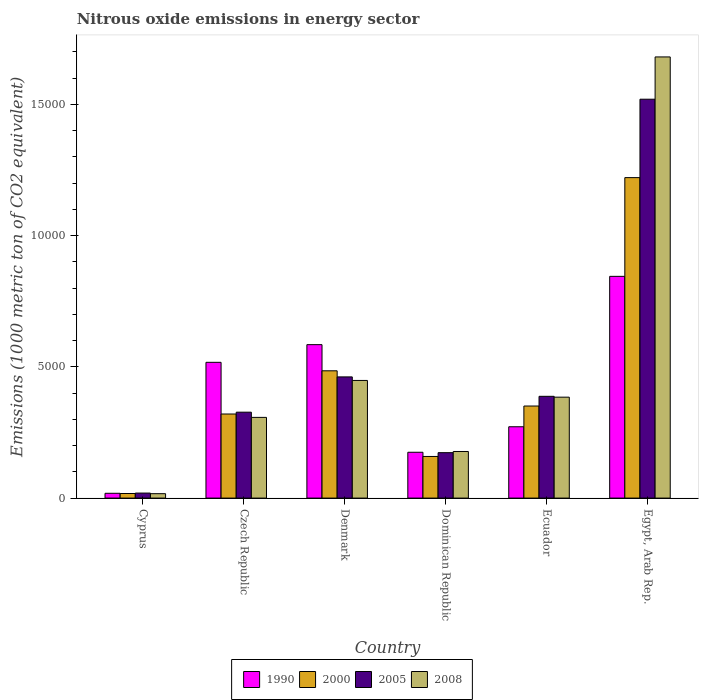How many different coloured bars are there?
Keep it short and to the point. 4. Are the number of bars on each tick of the X-axis equal?
Offer a terse response. Yes. How many bars are there on the 3rd tick from the left?
Ensure brevity in your answer.  4. How many bars are there on the 3rd tick from the right?
Your answer should be compact. 4. What is the label of the 1st group of bars from the left?
Your response must be concise. Cyprus. What is the amount of nitrous oxide emitted in 2008 in Czech Republic?
Provide a short and direct response. 3075.6. Across all countries, what is the maximum amount of nitrous oxide emitted in 2008?
Keep it short and to the point. 1.68e+04. Across all countries, what is the minimum amount of nitrous oxide emitted in 2005?
Your answer should be compact. 191.4. In which country was the amount of nitrous oxide emitted in 2008 maximum?
Provide a succinct answer. Egypt, Arab Rep. In which country was the amount of nitrous oxide emitted in 2005 minimum?
Keep it short and to the point. Cyprus. What is the total amount of nitrous oxide emitted in 2005 in the graph?
Your answer should be compact. 2.89e+04. What is the difference between the amount of nitrous oxide emitted in 2008 in Czech Republic and that in Ecuador?
Provide a short and direct response. -770.4. What is the difference between the amount of nitrous oxide emitted in 2008 in Denmark and the amount of nitrous oxide emitted in 1990 in Ecuador?
Your answer should be very brief. 1764.9. What is the average amount of nitrous oxide emitted in 2008 per country?
Your answer should be very brief. 5026.67. What is the difference between the amount of nitrous oxide emitted of/in 2000 and amount of nitrous oxide emitted of/in 2005 in Czech Republic?
Give a very brief answer. -69.6. What is the ratio of the amount of nitrous oxide emitted in 2008 in Czech Republic to that in Dominican Republic?
Offer a terse response. 1.73. What is the difference between the highest and the second highest amount of nitrous oxide emitted in 1990?
Give a very brief answer. 3275.8. What is the difference between the highest and the lowest amount of nitrous oxide emitted in 2005?
Provide a succinct answer. 1.50e+04. In how many countries, is the amount of nitrous oxide emitted in 2008 greater than the average amount of nitrous oxide emitted in 2008 taken over all countries?
Your response must be concise. 1. Is the sum of the amount of nitrous oxide emitted in 2000 in Cyprus and Egypt, Arab Rep. greater than the maximum amount of nitrous oxide emitted in 2008 across all countries?
Keep it short and to the point. No. What does the 2nd bar from the left in Cyprus represents?
Make the answer very short. 2000. How many countries are there in the graph?
Make the answer very short. 6. What is the difference between two consecutive major ticks on the Y-axis?
Give a very brief answer. 5000. Are the values on the major ticks of Y-axis written in scientific E-notation?
Offer a very short reply. No. Does the graph contain any zero values?
Keep it short and to the point. No. How many legend labels are there?
Your answer should be very brief. 4. What is the title of the graph?
Give a very brief answer. Nitrous oxide emissions in energy sector. What is the label or title of the X-axis?
Your answer should be very brief. Country. What is the label or title of the Y-axis?
Give a very brief answer. Emissions (1000 metric ton of CO2 equivalent). What is the Emissions (1000 metric ton of CO2 equivalent) in 1990 in Cyprus?
Make the answer very short. 182.9. What is the Emissions (1000 metric ton of CO2 equivalent) in 2000 in Cyprus?
Offer a terse response. 174.6. What is the Emissions (1000 metric ton of CO2 equivalent) of 2005 in Cyprus?
Your response must be concise. 191.4. What is the Emissions (1000 metric ton of CO2 equivalent) in 2008 in Cyprus?
Your answer should be very brief. 167.9. What is the Emissions (1000 metric ton of CO2 equivalent) in 1990 in Czech Republic?
Provide a short and direct response. 5174.1. What is the Emissions (1000 metric ton of CO2 equivalent) in 2000 in Czech Republic?
Give a very brief answer. 3204.1. What is the Emissions (1000 metric ton of CO2 equivalent) of 2005 in Czech Republic?
Offer a very short reply. 3273.7. What is the Emissions (1000 metric ton of CO2 equivalent) of 2008 in Czech Republic?
Your response must be concise. 3075.6. What is the Emissions (1000 metric ton of CO2 equivalent) in 1990 in Denmark?
Give a very brief answer. 5847.4. What is the Emissions (1000 metric ton of CO2 equivalent) of 2000 in Denmark?
Provide a short and direct response. 4850.8. What is the Emissions (1000 metric ton of CO2 equivalent) in 2005 in Denmark?
Offer a very short reply. 4618.6. What is the Emissions (1000 metric ton of CO2 equivalent) of 2008 in Denmark?
Your answer should be compact. 4483.4. What is the Emissions (1000 metric ton of CO2 equivalent) of 1990 in Dominican Republic?
Your response must be concise. 1746.5. What is the Emissions (1000 metric ton of CO2 equivalent) of 2000 in Dominican Republic?
Give a very brief answer. 1586.4. What is the Emissions (1000 metric ton of CO2 equivalent) of 2005 in Dominican Republic?
Make the answer very short. 1731. What is the Emissions (1000 metric ton of CO2 equivalent) in 2008 in Dominican Republic?
Your answer should be very brief. 1775.7. What is the Emissions (1000 metric ton of CO2 equivalent) of 1990 in Ecuador?
Provide a short and direct response. 2718.5. What is the Emissions (1000 metric ton of CO2 equivalent) in 2000 in Ecuador?
Provide a short and direct response. 3508.3. What is the Emissions (1000 metric ton of CO2 equivalent) of 2005 in Ecuador?
Your answer should be very brief. 3878.5. What is the Emissions (1000 metric ton of CO2 equivalent) in 2008 in Ecuador?
Keep it short and to the point. 3846. What is the Emissions (1000 metric ton of CO2 equivalent) in 1990 in Egypt, Arab Rep.?
Provide a short and direct response. 8449.9. What is the Emissions (1000 metric ton of CO2 equivalent) of 2000 in Egypt, Arab Rep.?
Make the answer very short. 1.22e+04. What is the Emissions (1000 metric ton of CO2 equivalent) of 2005 in Egypt, Arab Rep.?
Your response must be concise. 1.52e+04. What is the Emissions (1000 metric ton of CO2 equivalent) in 2008 in Egypt, Arab Rep.?
Keep it short and to the point. 1.68e+04. Across all countries, what is the maximum Emissions (1000 metric ton of CO2 equivalent) in 1990?
Give a very brief answer. 8449.9. Across all countries, what is the maximum Emissions (1000 metric ton of CO2 equivalent) in 2000?
Your response must be concise. 1.22e+04. Across all countries, what is the maximum Emissions (1000 metric ton of CO2 equivalent) of 2005?
Your answer should be compact. 1.52e+04. Across all countries, what is the maximum Emissions (1000 metric ton of CO2 equivalent) of 2008?
Keep it short and to the point. 1.68e+04. Across all countries, what is the minimum Emissions (1000 metric ton of CO2 equivalent) of 1990?
Your answer should be very brief. 182.9. Across all countries, what is the minimum Emissions (1000 metric ton of CO2 equivalent) in 2000?
Give a very brief answer. 174.6. Across all countries, what is the minimum Emissions (1000 metric ton of CO2 equivalent) of 2005?
Your answer should be very brief. 191.4. Across all countries, what is the minimum Emissions (1000 metric ton of CO2 equivalent) in 2008?
Give a very brief answer. 167.9. What is the total Emissions (1000 metric ton of CO2 equivalent) of 1990 in the graph?
Provide a short and direct response. 2.41e+04. What is the total Emissions (1000 metric ton of CO2 equivalent) in 2000 in the graph?
Your answer should be very brief. 2.55e+04. What is the total Emissions (1000 metric ton of CO2 equivalent) in 2005 in the graph?
Keep it short and to the point. 2.89e+04. What is the total Emissions (1000 metric ton of CO2 equivalent) of 2008 in the graph?
Make the answer very short. 3.02e+04. What is the difference between the Emissions (1000 metric ton of CO2 equivalent) in 1990 in Cyprus and that in Czech Republic?
Offer a terse response. -4991.2. What is the difference between the Emissions (1000 metric ton of CO2 equivalent) of 2000 in Cyprus and that in Czech Republic?
Ensure brevity in your answer.  -3029.5. What is the difference between the Emissions (1000 metric ton of CO2 equivalent) in 2005 in Cyprus and that in Czech Republic?
Your answer should be compact. -3082.3. What is the difference between the Emissions (1000 metric ton of CO2 equivalent) of 2008 in Cyprus and that in Czech Republic?
Offer a terse response. -2907.7. What is the difference between the Emissions (1000 metric ton of CO2 equivalent) of 1990 in Cyprus and that in Denmark?
Ensure brevity in your answer.  -5664.5. What is the difference between the Emissions (1000 metric ton of CO2 equivalent) in 2000 in Cyprus and that in Denmark?
Provide a succinct answer. -4676.2. What is the difference between the Emissions (1000 metric ton of CO2 equivalent) of 2005 in Cyprus and that in Denmark?
Keep it short and to the point. -4427.2. What is the difference between the Emissions (1000 metric ton of CO2 equivalent) of 2008 in Cyprus and that in Denmark?
Offer a terse response. -4315.5. What is the difference between the Emissions (1000 metric ton of CO2 equivalent) in 1990 in Cyprus and that in Dominican Republic?
Give a very brief answer. -1563.6. What is the difference between the Emissions (1000 metric ton of CO2 equivalent) in 2000 in Cyprus and that in Dominican Republic?
Provide a short and direct response. -1411.8. What is the difference between the Emissions (1000 metric ton of CO2 equivalent) in 2005 in Cyprus and that in Dominican Republic?
Provide a short and direct response. -1539.6. What is the difference between the Emissions (1000 metric ton of CO2 equivalent) of 2008 in Cyprus and that in Dominican Republic?
Your answer should be very brief. -1607.8. What is the difference between the Emissions (1000 metric ton of CO2 equivalent) in 1990 in Cyprus and that in Ecuador?
Keep it short and to the point. -2535.6. What is the difference between the Emissions (1000 metric ton of CO2 equivalent) in 2000 in Cyprus and that in Ecuador?
Give a very brief answer. -3333.7. What is the difference between the Emissions (1000 metric ton of CO2 equivalent) in 2005 in Cyprus and that in Ecuador?
Give a very brief answer. -3687.1. What is the difference between the Emissions (1000 metric ton of CO2 equivalent) in 2008 in Cyprus and that in Ecuador?
Keep it short and to the point. -3678.1. What is the difference between the Emissions (1000 metric ton of CO2 equivalent) of 1990 in Cyprus and that in Egypt, Arab Rep.?
Provide a succinct answer. -8267. What is the difference between the Emissions (1000 metric ton of CO2 equivalent) in 2000 in Cyprus and that in Egypt, Arab Rep.?
Your answer should be very brief. -1.20e+04. What is the difference between the Emissions (1000 metric ton of CO2 equivalent) of 2005 in Cyprus and that in Egypt, Arab Rep.?
Ensure brevity in your answer.  -1.50e+04. What is the difference between the Emissions (1000 metric ton of CO2 equivalent) of 2008 in Cyprus and that in Egypt, Arab Rep.?
Your answer should be very brief. -1.66e+04. What is the difference between the Emissions (1000 metric ton of CO2 equivalent) in 1990 in Czech Republic and that in Denmark?
Your answer should be very brief. -673.3. What is the difference between the Emissions (1000 metric ton of CO2 equivalent) in 2000 in Czech Republic and that in Denmark?
Provide a short and direct response. -1646.7. What is the difference between the Emissions (1000 metric ton of CO2 equivalent) in 2005 in Czech Republic and that in Denmark?
Offer a terse response. -1344.9. What is the difference between the Emissions (1000 metric ton of CO2 equivalent) in 2008 in Czech Republic and that in Denmark?
Keep it short and to the point. -1407.8. What is the difference between the Emissions (1000 metric ton of CO2 equivalent) in 1990 in Czech Republic and that in Dominican Republic?
Your response must be concise. 3427.6. What is the difference between the Emissions (1000 metric ton of CO2 equivalent) in 2000 in Czech Republic and that in Dominican Republic?
Provide a short and direct response. 1617.7. What is the difference between the Emissions (1000 metric ton of CO2 equivalent) of 2005 in Czech Republic and that in Dominican Republic?
Ensure brevity in your answer.  1542.7. What is the difference between the Emissions (1000 metric ton of CO2 equivalent) of 2008 in Czech Republic and that in Dominican Republic?
Give a very brief answer. 1299.9. What is the difference between the Emissions (1000 metric ton of CO2 equivalent) in 1990 in Czech Republic and that in Ecuador?
Offer a very short reply. 2455.6. What is the difference between the Emissions (1000 metric ton of CO2 equivalent) in 2000 in Czech Republic and that in Ecuador?
Your response must be concise. -304.2. What is the difference between the Emissions (1000 metric ton of CO2 equivalent) in 2005 in Czech Republic and that in Ecuador?
Provide a succinct answer. -604.8. What is the difference between the Emissions (1000 metric ton of CO2 equivalent) in 2008 in Czech Republic and that in Ecuador?
Offer a very short reply. -770.4. What is the difference between the Emissions (1000 metric ton of CO2 equivalent) in 1990 in Czech Republic and that in Egypt, Arab Rep.?
Give a very brief answer. -3275.8. What is the difference between the Emissions (1000 metric ton of CO2 equivalent) in 2000 in Czech Republic and that in Egypt, Arab Rep.?
Offer a very short reply. -9008.3. What is the difference between the Emissions (1000 metric ton of CO2 equivalent) in 2005 in Czech Republic and that in Egypt, Arab Rep.?
Your response must be concise. -1.19e+04. What is the difference between the Emissions (1000 metric ton of CO2 equivalent) in 2008 in Czech Republic and that in Egypt, Arab Rep.?
Provide a succinct answer. -1.37e+04. What is the difference between the Emissions (1000 metric ton of CO2 equivalent) of 1990 in Denmark and that in Dominican Republic?
Offer a terse response. 4100.9. What is the difference between the Emissions (1000 metric ton of CO2 equivalent) of 2000 in Denmark and that in Dominican Republic?
Make the answer very short. 3264.4. What is the difference between the Emissions (1000 metric ton of CO2 equivalent) in 2005 in Denmark and that in Dominican Republic?
Give a very brief answer. 2887.6. What is the difference between the Emissions (1000 metric ton of CO2 equivalent) in 2008 in Denmark and that in Dominican Republic?
Keep it short and to the point. 2707.7. What is the difference between the Emissions (1000 metric ton of CO2 equivalent) of 1990 in Denmark and that in Ecuador?
Provide a succinct answer. 3128.9. What is the difference between the Emissions (1000 metric ton of CO2 equivalent) in 2000 in Denmark and that in Ecuador?
Give a very brief answer. 1342.5. What is the difference between the Emissions (1000 metric ton of CO2 equivalent) in 2005 in Denmark and that in Ecuador?
Give a very brief answer. 740.1. What is the difference between the Emissions (1000 metric ton of CO2 equivalent) in 2008 in Denmark and that in Ecuador?
Ensure brevity in your answer.  637.4. What is the difference between the Emissions (1000 metric ton of CO2 equivalent) in 1990 in Denmark and that in Egypt, Arab Rep.?
Give a very brief answer. -2602.5. What is the difference between the Emissions (1000 metric ton of CO2 equivalent) in 2000 in Denmark and that in Egypt, Arab Rep.?
Provide a succinct answer. -7361.6. What is the difference between the Emissions (1000 metric ton of CO2 equivalent) of 2005 in Denmark and that in Egypt, Arab Rep.?
Give a very brief answer. -1.06e+04. What is the difference between the Emissions (1000 metric ton of CO2 equivalent) of 2008 in Denmark and that in Egypt, Arab Rep.?
Keep it short and to the point. -1.23e+04. What is the difference between the Emissions (1000 metric ton of CO2 equivalent) of 1990 in Dominican Republic and that in Ecuador?
Offer a very short reply. -972. What is the difference between the Emissions (1000 metric ton of CO2 equivalent) of 2000 in Dominican Republic and that in Ecuador?
Your answer should be compact. -1921.9. What is the difference between the Emissions (1000 metric ton of CO2 equivalent) of 2005 in Dominican Republic and that in Ecuador?
Ensure brevity in your answer.  -2147.5. What is the difference between the Emissions (1000 metric ton of CO2 equivalent) of 2008 in Dominican Republic and that in Ecuador?
Offer a very short reply. -2070.3. What is the difference between the Emissions (1000 metric ton of CO2 equivalent) in 1990 in Dominican Republic and that in Egypt, Arab Rep.?
Your answer should be compact. -6703.4. What is the difference between the Emissions (1000 metric ton of CO2 equivalent) in 2000 in Dominican Republic and that in Egypt, Arab Rep.?
Your answer should be very brief. -1.06e+04. What is the difference between the Emissions (1000 metric ton of CO2 equivalent) in 2005 in Dominican Republic and that in Egypt, Arab Rep.?
Your response must be concise. -1.35e+04. What is the difference between the Emissions (1000 metric ton of CO2 equivalent) in 2008 in Dominican Republic and that in Egypt, Arab Rep.?
Provide a succinct answer. -1.50e+04. What is the difference between the Emissions (1000 metric ton of CO2 equivalent) of 1990 in Ecuador and that in Egypt, Arab Rep.?
Your response must be concise. -5731.4. What is the difference between the Emissions (1000 metric ton of CO2 equivalent) of 2000 in Ecuador and that in Egypt, Arab Rep.?
Your answer should be compact. -8704.1. What is the difference between the Emissions (1000 metric ton of CO2 equivalent) of 2005 in Ecuador and that in Egypt, Arab Rep.?
Offer a terse response. -1.13e+04. What is the difference between the Emissions (1000 metric ton of CO2 equivalent) of 2008 in Ecuador and that in Egypt, Arab Rep.?
Your response must be concise. -1.30e+04. What is the difference between the Emissions (1000 metric ton of CO2 equivalent) in 1990 in Cyprus and the Emissions (1000 metric ton of CO2 equivalent) in 2000 in Czech Republic?
Give a very brief answer. -3021.2. What is the difference between the Emissions (1000 metric ton of CO2 equivalent) in 1990 in Cyprus and the Emissions (1000 metric ton of CO2 equivalent) in 2005 in Czech Republic?
Offer a terse response. -3090.8. What is the difference between the Emissions (1000 metric ton of CO2 equivalent) of 1990 in Cyprus and the Emissions (1000 metric ton of CO2 equivalent) of 2008 in Czech Republic?
Offer a very short reply. -2892.7. What is the difference between the Emissions (1000 metric ton of CO2 equivalent) in 2000 in Cyprus and the Emissions (1000 metric ton of CO2 equivalent) in 2005 in Czech Republic?
Offer a terse response. -3099.1. What is the difference between the Emissions (1000 metric ton of CO2 equivalent) in 2000 in Cyprus and the Emissions (1000 metric ton of CO2 equivalent) in 2008 in Czech Republic?
Offer a very short reply. -2901. What is the difference between the Emissions (1000 metric ton of CO2 equivalent) of 2005 in Cyprus and the Emissions (1000 metric ton of CO2 equivalent) of 2008 in Czech Republic?
Your response must be concise. -2884.2. What is the difference between the Emissions (1000 metric ton of CO2 equivalent) in 1990 in Cyprus and the Emissions (1000 metric ton of CO2 equivalent) in 2000 in Denmark?
Your answer should be compact. -4667.9. What is the difference between the Emissions (1000 metric ton of CO2 equivalent) of 1990 in Cyprus and the Emissions (1000 metric ton of CO2 equivalent) of 2005 in Denmark?
Your answer should be very brief. -4435.7. What is the difference between the Emissions (1000 metric ton of CO2 equivalent) in 1990 in Cyprus and the Emissions (1000 metric ton of CO2 equivalent) in 2008 in Denmark?
Provide a short and direct response. -4300.5. What is the difference between the Emissions (1000 metric ton of CO2 equivalent) in 2000 in Cyprus and the Emissions (1000 metric ton of CO2 equivalent) in 2005 in Denmark?
Offer a terse response. -4444. What is the difference between the Emissions (1000 metric ton of CO2 equivalent) in 2000 in Cyprus and the Emissions (1000 metric ton of CO2 equivalent) in 2008 in Denmark?
Offer a very short reply. -4308.8. What is the difference between the Emissions (1000 metric ton of CO2 equivalent) in 2005 in Cyprus and the Emissions (1000 metric ton of CO2 equivalent) in 2008 in Denmark?
Provide a short and direct response. -4292. What is the difference between the Emissions (1000 metric ton of CO2 equivalent) in 1990 in Cyprus and the Emissions (1000 metric ton of CO2 equivalent) in 2000 in Dominican Republic?
Your answer should be very brief. -1403.5. What is the difference between the Emissions (1000 metric ton of CO2 equivalent) of 1990 in Cyprus and the Emissions (1000 metric ton of CO2 equivalent) of 2005 in Dominican Republic?
Provide a short and direct response. -1548.1. What is the difference between the Emissions (1000 metric ton of CO2 equivalent) in 1990 in Cyprus and the Emissions (1000 metric ton of CO2 equivalent) in 2008 in Dominican Republic?
Your answer should be very brief. -1592.8. What is the difference between the Emissions (1000 metric ton of CO2 equivalent) of 2000 in Cyprus and the Emissions (1000 metric ton of CO2 equivalent) of 2005 in Dominican Republic?
Keep it short and to the point. -1556.4. What is the difference between the Emissions (1000 metric ton of CO2 equivalent) of 2000 in Cyprus and the Emissions (1000 metric ton of CO2 equivalent) of 2008 in Dominican Republic?
Make the answer very short. -1601.1. What is the difference between the Emissions (1000 metric ton of CO2 equivalent) of 2005 in Cyprus and the Emissions (1000 metric ton of CO2 equivalent) of 2008 in Dominican Republic?
Keep it short and to the point. -1584.3. What is the difference between the Emissions (1000 metric ton of CO2 equivalent) of 1990 in Cyprus and the Emissions (1000 metric ton of CO2 equivalent) of 2000 in Ecuador?
Your answer should be compact. -3325.4. What is the difference between the Emissions (1000 metric ton of CO2 equivalent) in 1990 in Cyprus and the Emissions (1000 metric ton of CO2 equivalent) in 2005 in Ecuador?
Offer a terse response. -3695.6. What is the difference between the Emissions (1000 metric ton of CO2 equivalent) in 1990 in Cyprus and the Emissions (1000 metric ton of CO2 equivalent) in 2008 in Ecuador?
Make the answer very short. -3663.1. What is the difference between the Emissions (1000 metric ton of CO2 equivalent) in 2000 in Cyprus and the Emissions (1000 metric ton of CO2 equivalent) in 2005 in Ecuador?
Ensure brevity in your answer.  -3703.9. What is the difference between the Emissions (1000 metric ton of CO2 equivalent) of 2000 in Cyprus and the Emissions (1000 metric ton of CO2 equivalent) of 2008 in Ecuador?
Make the answer very short. -3671.4. What is the difference between the Emissions (1000 metric ton of CO2 equivalent) in 2005 in Cyprus and the Emissions (1000 metric ton of CO2 equivalent) in 2008 in Ecuador?
Your answer should be very brief. -3654.6. What is the difference between the Emissions (1000 metric ton of CO2 equivalent) in 1990 in Cyprus and the Emissions (1000 metric ton of CO2 equivalent) in 2000 in Egypt, Arab Rep.?
Your answer should be very brief. -1.20e+04. What is the difference between the Emissions (1000 metric ton of CO2 equivalent) of 1990 in Cyprus and the Emissions (1000 metric ton of CO2 equivalent) of 2005 in Egypt, Arab Rep.?
Make the answer very short. -1.50e+04. What is the difference between the Emissions (1000 metric ton of CO2 equivalent) in 1990 in Cyprus and the Emissions (1000 metric ton of CO2 equivalent) in 2008 in Egypt, Arab Rep.?
Make the answer very short. -1.66e+04. What is the difference between the Emissions (1000 metric ton of CO2 equivalent) of 2000 in Cyprus and the Emissions (1000 metric ton of CO2 equivalent) of 2005 in Egypt, Arab Rep.?
Offer a terse response. -1.50e+04. What is the difference between the Emissions (1000 metric ton of CO2 equivalent) of 2000 in Cyprus and the Emissions (1000 metric ton of CO2 equivalent) of 2008 in Egypt, Arab Rep.?
Your response must be concise. -1.66e+04. What is the difference between the Emissions (1000 metric ton of CO2 equivalent) of 2005 in Cyprus and the Emissions (1000 metric ton of CO2 equivalent) of 2008 in Egypt, Arab Rep.?
Provide a succinct answer. -1.66e+04. What is the difference between the Emissions (1000 metric ton of CO2 equivalent) of 1990 in Czech Republic and the Emissions (1000 metric ton of CO2 equivalent) of 2000 in Denmark?
Ensure brevity in your answer.  323.3. What is the difference between the Emissions (1000 metric ton of CO2 equivalent) in 1990 in Czech Republic and the Emissions (1000 metric ton of CO2 equivalent) in 2005 in Denmark?
Your answer should be compact. 555.5. What is the difference between the Emissions (1000 metric ton of CO2 equivalent) of 1990 in Czech Republic and the Emissions (1000 metric ton of CO2 equivalent) of 2008 in Denmark?
Provide a short and direct response. 690.7. What is the difference between the Emissions (1000 metric ton of CO2 equivalent) of 2000 in Czech Republic and the Emissions (1000 metric ton of CO2 equivalent) of 2005 in Denmark?
Offer a terse response. -1414.5. What is the difference between the Emissions (1000 metric ton of CO2 equivalent) of 2000 in Czech Republic and the Emissions (1000 metric ton of CO2 equivalent) of 2008 in Denmark?
Keep it short and to the point. -1279.3. What is the difference between the Emissions (1000 metric ton of CO2 equivalent) in 2005 in Czech Republic and the Emissions (1000 metric ton of CO2 equivalent) in 2008 in Denmark?
Offer a terse response. -1209.7. What is the difference between the Emissions (1000 metric ton of CO2 equivalent) of 1990 in Czech Republic and the Emissions (1000 metric ton of CO2 equivalent) of 2000 in Dominican Republic?
Your answer should be very brief. 3587.7. What is the difference between the Emissions (1000 metric ton of CO2 equivalent) in 1990 in Czech Republic and the Emissions (1000 metric ton of CO2 equivalent) in 2005 in Dominican Republic?
Your answer should be compact. 3443.1. What is the difference between the Emissions (1000 metric ton of CO2 equivalent) of 1990 in Czech Republic and the Emissions (1000 metric ton of CO2 equivalent) of 2008 in Dominican Republic?
Offer a very short reply. 3398.4. What is the difference between the Emissions (1000 metric ton of CO2 equivalent) of 2000 in Czech Republic and the Emissions (1000 metric ton of CO2 equivalent) of 2005 in Dominican Republic?
Offer a very short reply. 1473.1. What is the difference between the Emissions (1000 metric ton of CO2 equivalent) of 2000 in Czech Republic and the Emissions (1000 metric ton of CO2 equivalent) of 2008 in Dominican Republic?
Make the answer very short. 1428.4. What is the difference between the Emissions (1000 metric ton of CO2 equivalent) of 2005 in Czech Republic and the Emissions (1000 metric ton of CO2 equivalent) of 2008 in Dominican Republic?
Your answer should be very brief. 1498. What is the difference between the Emissions (1000 metric ton of CO2 equivalent) in 1990 in Czech Republic and the Emissions (1000 metric ton of CO2 equivalent) in 2000 in Ecuador?
Give a very brief answer. 1665.8. What is the difference between the Emissions (1000 metric ton of CO2 equivalent) in 1990 in Czech Republic and the Emissions (1000 metric ton of CO2 equivalent) in 2005 in Ecuador?
Give a very brief answer. 1295.6. What is the difference between the Emissions (1000 metric ton of CO2 equivalent) in 1990 in Czech Republic and the Emissions (1000 metric ton of CO2 equivalent) in 2008 in Ecuador?
Make the answer very short. 1328.1. What is the difference between the Emissions (1000 metric ton of CO2 equivalent) in 2000 in Czech Republic and the Emissions (1000 metric ton of CO2 equivalent) in 2005 in Ecuador?
Provide a short and direct response. -674.4. What is the difference between the Emissions (1000 metric ton of CO2 equivalent) in 2000 in Czech Republic and the Emissions (1000 metric ton of CO2 equivalent) in 2008 in Ecuador?
Offer a very short reply. -641.9. What is the difference between the Emissions (1000 metric ton of CO2 equivalent) in 2005 in Czech Republic and the Emissions (1000 metric ton of CO2 equivalent) in 2008 in Ecuador?
Provide a short and direct response. -572.3. What is the difference between the Emissions (1000 metric ton of CO2 equivalent) of 1990 in Czech Republic and the Emissions (1000 metric ton of CO2 equivalent) of 2000 in Egypt, Arab Rep.?
Offer a terse response. -7038.3. What is the difference between the Emissions (1000 metric ton of CO2 equivalent) of 1990 in Czech Republic and the Emissions (1000 metric ton of CO2 equivalent) of 2005 in Egypt, Arab Rep.?
Give a very brief answer. -1.00e+04. What is the difference between the Emissions (1000 metric ton of CO2 equivalent) of 1990 in Czech Republic and the Emissions (1000 metric ton of CO2 equivalent) of 2008 in Egypt, Arab Rep.?
Your answer should be compact. -1.16e+04. What is the difference between the Emissions (1000 metric ton of CO2 equivalent) in 2000 in Czech Republic and the Emissions (1000 metric ton of CO2 equivalent) in 2005 in Egypt, Arab Rep.?
Keep it short and to the point. -1.20e+04. What is the difference between the Emissions (1000 metric ton of CO2 equivalent) in 2000 in Czech Republic and the Emissions (1000 metric ton of CO2 equivalent) in 2008 in Egypt, Arab Rep.?
Keep it short and to the point. -1.36e+04. What is the difference between the Emissions (1000 metric ton of CO2 equivalent) of 2005 in Czech Republic and the Emissions (1000 metric ton of CO2 equivalent) of 2008 in Egypt, Arab Rep.?
Give a very brief answer. -1.35e+04. What is the difference between the Emissions (1000 metric ton of CO2 equivalent) in 1990 in Denmark and the Emissions (1000 metric ton of CO2 equivalent) in 2000 in Dominican Republic?
Offer a very short reply. 4261. What is the difference between the Emissions (1000 metric ton of CO2 equivalent) of 1990 in Denmark and the Emissions (1000 metric ton of CO2 equivalent) of 2005 in Dominican Republic?
Offer a very short reply. 4116.4. What is the difference between the Emissions (1000 metric ton of CO2 equivalent) of 1990 in Denmark and the Emissions (1000 metric ton of CO2 equivalent) of 2008 in Dominican Republic?
Offer a very short reply. 4071.7. What is the difference between the Emissions (1000 metric ton of CO2 equivalent) of 2000 in Denmark and the Emissions (1000 metric ton of CO2 equivalent) of 2005 in Dominican Republic?
Provide a short and direct response. 3119.8. What is the difference between the Emissions (1000 metric ton of CO2 equivalent) of 2000 in Denmark and the Emissions (1000 metric ton of CO2 equivalent) of 2008 in Dominican Republic?
Keep it short and to the point. 3075.1. What is the difference between the Emissions (1000 metric ton of CO2 equivalent) of 2005 in Denmark and the Emissions (1000 metric ton of CO2 equivalent) of 2008 in Dominican Republic?
Provide a succinct answer. 2842.9. What is the difference between the Emissions (1000 metric ton of CO2 equivalent) of 1990 in Denmark and the Emissions (1000 metric ton of CO2 equivalent) of 2000 in Ecuador?
Ensure brevity in your answer.  2339.1. What is the difference between the Emissions (1000 metric ton of CO2 equivalent) in 1990 in Denmark and the Emissions (1000 metric ton of CO2 equivalent) in 2005 in Ecuador?
Your answer should be compact. 1968.9. What is the difference between the Emissions (1000 metric ton of CO2 equivalent) of 1990 in Denmark and the Emissions (1000 metric ton of CO2 equivalent) of 2008 in Ecuador?
Make the answer very short. 2001.4. What is the difference between the Emissions (1000 metric ton of CO2 equivalent) in 2000 in Denmark and the Emissions (1000 metric ton of CO2 equivalent) in 2005 in Ecuador?
Ensure brevity in your answer.  972.3. What is the difference between the Emissions (1000 metric ton of CO2 equivalent) in 2000 in Denmark and the Emissions (1000 metric ton of CO2 equivalent) in 2008 in Ecuador?
Give a very brief answer. 1004.8. What is the difference between the Emissions (1000 metric ton of CO2 equivalent) in 2005 in Denmark and the Emissions (1000 metric ton of CO2 equivalent) in 2008 in Ecuador?
Give a very brief answer. 772.6. What is the difference between the Emissions (1000 metric ton of CO2 equivalent) in 1990 in Denmark and the Emissions (1000 metric ton of CO2 equivalent) in 2000 in Egypt, Arab Rep.?
Your answer should be compact. -6365. What is the difference between the Emissions (1000 metric ton of CO2 equivalent) of 1990 in Denmark and the Emissions (1000 metric ton of CO2 equivalent) of 2005 in Egypt, Arab Rep.?
Offer a terse response. -9352.6. What is the difference between the Emissions (1000 metric ton of CO2 equivalent) of 1990 in Denmark and the Emissions (1000 metric ton of CO2 equivalent) of 2008 in Egypt, Arab Rep.?
Keep it short and to the point. -1.10e+04. What is the difference between the Emissions (1000 metric ton of CO2 equivalent) in 2000 in Denmark and the Emissions (1000 metric ton of CO2 equivalent) in 2005 in Egypt, Arab Rep.?
Provide a short and direct response. -1.03e+04. What is the difference between the Emissions (1000 metric ton of CO2 equivalent) of 2000 in Denmark and the Emissions (1000 metric ton of CO2 equivalent) of 2008 in Egypt, Arab Rep.?
Keep it short and to the point. -1.20e+04. What is the difference between the Emissions (1000 metric ton of CO2 equivalent) in 2005 in Denmark and the Emissions (1000 metric ton of CO2 equivalent) in 2008 in Egypt, Arab Rep.?
Give a very brief answer. -1.22e+04. What is the difference between the Emissions (1000 metric ton of CO2 equivalent) of 1990 in Dominican Republic and the Emissions (1000 metric ton of CO2 equivalent) of 2000 in Ecuador?
Your response must be concise. -1761.8. What is the difference between the Emissions (1000 metric ton of CO2 equivalent) in 1990 in Dominican Republic and the Emissions (1000 metric ton of CO2 equivalent) in 2005 in Ecuador?
Offer a terse response. -2132. What is the difference between the Emissions (1000 metric ton of CO2 equivalent) in 1990 in Dominican Republic and the Emissions (1000 metric ton of CO2 equivalent) in 2008 in Ecuador?
Offer a very short reply. -2099.5. What is the difference between the Emissions (1000 metric ton of CO2 equivalent) in 2000 in Dominican Republic and the Emissions (1000 metric ton of CO2 equivalent) in 2005 in Ecuador?
Your answer should be very brief. -2292.1. What is the difference between the Emissions (1000 metric ton of CO2 equivalent) in 2000 in Dominican Republic and the Emissions (1000 metric ton of CO2 equivalent) in 2008 in Ecuador?
Your answer should be compact. -2259.6. What is the difference between the Emissions (1000 metric ton of CO2 equivalent) in 2005 in Dominican Republic and the Emissions (1000 metric ton of CO2 equivalent) in 2008 in Ecuador?
Offer a terse response. -2115. What is the difference between the Emissions (1000 metric ton of CO2 equivalent) of 1990 in Dominican Republic and the Emissions (1000 metric ton of CO2 equivalent) of 2000 in Egypt, Arab Rep.?
Offer a terse response. -1.05e+04. What is the difference between the Emissions (1000 metric ton of CO2 equivalent) in 1990 in Dominican Republic and the Emissions (1000 metric ton of CO2 equivalent) in 2005 in Egypt, Arab Rep.?
Keep it short and to the point. -1.35e+04. What is the difference between the Emissions (1000 metric ton of CO2 equivalent) of 1990 in Dominican Republic and the Emissions (1000 metric ton of CO2 equivalent) of 2008 in Egypt, Arab Rep.?
Your answer should be very brief. -1.51e+04. What is the difference between the Emissions (1000 metric ton of CO2 equivalent) in 2000 in Dominican Republic and the Emissions (1000 metric ton of CO2 equivalent) in 2005 in Egypt, Arab Rep.?
Provide a succinct answer. -1.36e+04. What is the difference between the Emissions (1000 metric ton of CO2 equivalent) of 2000 in Dominican Republic and the Emissions (1000 metric ton of CO2 equivalent) of 2008 in Egypt, Arab Rep.?
Provide a succinct answer. -1.52e+04. What is the difference between the Emissions (1000 metric ton of CO2 equivalent) in 2005 in Dominican Republic and the Emissions (1000 metric ton of CO2 equivalent) in 2008 in Egypt, Arab Rep.?
Your answer should be compact. -1.51e+04. What is the difference between the Emissions (1000 metric ton of CO2 equivalent) in 1990 in Ecuador and the Emissions (1000 metric ton of CO2 equivalent) in 2000 in Egypt, Arab Rep.?
Your response must be concise. -9493.9. What is the difference between the Emissions (1000 metric ton of CO2 equivalent) in 1990 in Ecuador and the Emissions (1000 metric ton of CO2 equivalent) in 2005 in Egypt, Arab Rep.?
Offer a very short reply. -1.25e+04. What is the difference between the Emissions (1000 metric ton of CO2 equivalent) in 1990 in Ecuador and the Emissions (1000 metric ton of CO2 equivalent) in 2008 in Egypt, Arab Rep.?
Your answer should be compact. -1.41e+04. What is the difference between the Emissions (1000 metric ton of CO2 equivalent) in 2000 in Ecuador and the Emissions (1000 metric ton of CO2 equivalent) in 2005 in Egypt, Arab Rep.?
Provide a short and direct response. -1.17e+04. What is the difference between the Emissions (1000 metric ton of CO2 equivalent) in 2000 in Ecuador and the Emissions (1000 metric ton of CO2 equivalent) in 2008 in Egypt, Arab Rep.?
Provide a short and direct response. -1.33e+04. What is the difference between the Emissions (1000 metric ton of CO2 equivalent) in 2005 in Ecuador and the Emissions (1000 metric ton of CO2 equivalent) in 2008 in Egypt, Arab Rep.?
Keep it short and to the point. -1.29e+04. What is the average Emissions (1000 metric ton of CO2 equivalent) of 1990 per country?
Provide a succinct answer. 4019.88. What is the average Emissions (1000 metric ton of CO2 equivalent) in 2000 per country?
Your response must be concise. 4256.1. What is the average Emissions (1000 metric ton of CO2 equivalent) of 2005 per country?
Offer a very short reply. 4815.53. What is the average Emissions (1000 metric ton of CO2 equivalent) in 2008 per country?
Provide a succinct answer. 5026.67. What is the difference between the Emissions (1000 metric ton of CO2 equivalent) in 1990 and Emissions (1000 metric ton of CO2 equivalent) in 2000 in Cyprus?
Your response must be concise. 8.3. What is the difference between the Emissions (1000 metric ton of CO2 equivalent) in 1990 and Emissions (1000 metric ton of CO2 equivalent) in 2008 in Cyprus?
Offer a terse response. 15. What is the difference between the Emissions (1000 metric ton of CO2 equivalent) in 2000 and Emissions (1000 metric ton of CO2 equivalent) in 2005 in Cyprus?
Provide a succinct answer. -16.8. What is the difference between the Emissions (1000 metric ton of CO2 equivalent) of 2005 and Emissions (1000 metric ton of CO2 equivalent) of 2008 in Cyprus?
Your answer should be compact. 23.5. What is the difference between the Emissions (1000 metric ton of CO2 equivalent) of 1990 and Emissions (1000 metric ton of CO2 equivalent) of 2000 in Czech Republic?
Your answer should be compact. 1970. What is the difference between the Emissions (1000 metric ton of CO2 equivalent) of 1990 and Emissions (1000 metric ton of CO2 equivalent) of 2005 in Czech Republic?
Provide a succinct answer. 1900.4. What is the difference between the Emissions (1000 metric ton of CO2 equivalent) of 1990 and Emissions (1000 metric ton of CO2 equivalent) of 2008 in Czech Republic?
Provide a succinct answer. 2098.5. What is the difference between the Emissions (1000 metric ton of CO2 equivalent) in 2000 and Emissions (1000 metric ton of CO2 equivalent) in 2005 in Czech Republic?
Your response must be concise. -69.6. What is the difference between the Emissions (1000 metric ton of CO2 equivalent) of 2000 and Emissions (1000 metric ton of CO2 equivalent) of 2008 in Czech Republic?
Offer a terse response. 128.5. What is the difference between the Emissions (1000 metric ton of CO2 equivalent) of 2005 and Emissions (1000 metric ton of CO2 equivalent) of 2008 in Czech Republic?
Provide a short and direct response. 198.1. What is the difference between the Emissions (1000 metric ton of CO2 equivalent) in 1990 and Emissions (1000 metric ton of CO2 equivalent) in 2000 in Denmark?
Provide a short and direct response. 996.6. What is the difference between the Emissions (1000 metric ton of CO2 equivalent) in 1990 and Emissions (1000 metric ton of CO2 equivalent) in 2005 in Denmark?
Your response must be concise. 1228.8. What is the difference between the Emissions (1000 metric ton of CO2 equivalent) in 1990 and Emissions (1000 metric ton of CO2 equivalent) in 2008 in Denmark?
Give a very brief answer. 1364. What is the difference between the Emissions (1000 metric ton of CO2 equivalent) in 2000 and Emissions (1000 metric ton of CO2 equivalent) in 2005 in Denmark?
Offer a terse response. 232.2. What is the difference between the Emissions (1000 metric ton of CO2 equivalent) of 2000 and Emissions (1000 metric ton of CO2 equivalent) of 2008 in Denmark?
Offer a very short reply. 367.4. What is the difference between the Emissions (1000 metric ton of CO2 equivalent) of 2005 and Emissions (1000 metric ton of CO2 equivalent) of 2008 in Denmark?
Your response must be concise. 135.2. What is the difference between the Emissions (1000 metric ton of CO2 equivalent) in 1990 and Emissions (1000 metric ton of CO2 equivalent) in 2000 in Dominican Republic?
Give a very brief answer. 160.1. What is the difference between the Emissions (1000 metric ton of CO2 equivalent) of 1990 and Emissions (1000 metric ton of CO2 equivalent) of 2005 in Dominican Republic?
Offer a terse response. 15.5. What is the difference between the Emissions (1000 metric ton of CO2 equivalent) in 1990 and Emissions (1000 metric ton of CO2 equivalent) in 2008 in Dominican Republic?
Your answer should be very brief. -29.2. What is the difference between the Emissions (1000 metric ton of CO2 equivalent) in 2000 and Emissions (1000 metric ton of CO2 equivalent) in 2005 in Dominican Republic?
Offer a very short reply. -144.6. What is the difference between the Emissions (1000 metric ton of CO2 equivalent) in 2000 and Emissions (1000 metric ton of CO2 equivalent) in 2008 in Dominican Republic?
Keep it short and to the point. -189.3. What is the difference between the Emissions (1000 metric ton of CO2 equivalent) in 2005 and Emissions (1000 metric ton of CO2 equivalent) in 2008 in Dominican Republic?
Your response must be concise. -44.7. What is the difference between the Emissions (1000 metric ton of CO2 equivalent) of 1990 and Emissions (1000 metric ton of CO2 equivalent) of 2000 in Ecuador?
Offer a very short reply. -789.8. What is the difference between the Emissions (1000 metric ton of CO2 equivalent) of 1990 and Emissions (1000 metric ton of CO2 equivalent) of 2005 in Ecuador?
Provide a succinct answer. -1160. What is the difference between the Emissions (1000 metric ton of CO2 equivalent) in 1990 and Emissions (1000 metric ton of CO2 equivalent) in 2008 in Ecuador?
Keep it short and to the point. -1127.5. What is the difference between the Emissions (1000 metric ton of CO2 equivalent) in 2000 and Emissions (1000 metric ton of CO2 equivalent) in 2005 in Ecuador?
Provide a succinct answer. -370.2. What is the difference between the Emissions (1000 metric ton of CO2 equivalent) in 2000 and Emissions (1000 metric ton of CO2 equivalent) in 2008 in Ecuador?
Provide a succinct answer. -337.7. What is the difference between the Emissions (1000 metric ton of CO2 equivalent) of 2005 and Emissions (1000 metric ton of CO2 equivalent) of 2008 in Ecuador?
Provide a succinct answer. 32.5. What is the difference between the Emissions (1000 metric ton of CO2 equivalent) of 1990 and Emissions (1000 metric ton of CO2 equivalent) of 2000 in Egypt, Arab Rep.?
Give a very brief answer. -3762.5. What is the difference between the Emissions (1000 metric ton of CO2 equivalent) of 1990 and Emissions (1000 metric ton of CO2 equivalent) of 2005 in Egypt, Arab Rep.?
Offer a terse response. -6750.1. What is the difference between the Emissions (1000 metric ton of CO2 equivalent) in 1990 and Emissions (1000 metric ton of CO2 equivalent) in 2008 in Egypt, Arab Rep.?
Give a very brief answer. -8361.5. What is the difference between the Emissions (1000 metric ton of CO2 equivalent) of 2000 and Emissions (1000 metric ton of CO2 equivalent) of 2005 in Egypt, Arab Rep.?
Ensure brevity in your answer.  -2987.6. What is the difference between the Emissions (1000 metric ton of CO2 equivalent) in 2000 and Emissions (1000 metric ton of CO2 equivalent) in 2008 in Egypt, Arab Rep.?
Your answer should be compact. -4599. What is the difference between the Emissions (1000 metric ton of CO2 equivalent) in 2005 and Emissions (1000 metric ton of CO2 equivalent) in 2008 in Egypt, Arab Rep.?
Keep it short and to the point. -1611.4. What is the ratio of the Emissions (1000 metric ton of CO2 equivalent) of 1990 in Cyprus to that in Czech Republic?
Offer a terse response. 0.04. What is the ratio of the Emissions (1000 metric ton of CO2 equivalent) in 2000 in Cyprus to that in Czech Republic?
Provide a succinct answer. 0.05. What is the ratio of the Emissions (1000 metric ton of CO2 equivalent) in 2005 in Cyprus to that in Czech Republic?
Provide a succinct answer. 0.06. What is the ratio of the Emissions (1000 metric ton of CO2 equivalent) in 2008 in Cyprus to that in Czech Republic?
Make the answer very short. 0.05. What is the ratio of the Emissions (1000 metric ton of CO2 equivalent) of 1990 in Cyprus to that in Denmark?
Offer a terse response. 0.03. What is the ratio of the Emissions (1000 metric ton of CO2 equivalent) in 2000 in Cyprus to that in Denmark?
Your response must be concise. 0.04. What is the ratio of the Emissions (1000 metric ton of CO2 equivalent) in 2005 in Cyprus to that in Denmark?
Offer a terse response. 0.04. What is the ratio of the Emissions (1000 metric ton of CO2 equivalent) in 2008 in Cyprus to that in Denmark?
Your response must be concise. 0.04. What is the ratio of the Emissions (1000 metric ton of CO2 equivalent) of 1990 in Cyprus to that in Dominican Republic?
Offer a very short reply. 0.1. What is the ratio of the Emissions (1000 metric ton of CO2 equivalent) of 2000 in Cyprus to that in Dominican Republic?
Your answer should be compact. 0.11. What is the ratio of the Emissions (1000 metric ton of CO2 equivalent) in 2005 in Cyprus to that in Dominican Republic?
Ensure brevity in your answer.  0.11. What is the ratio of the Emissions (1000 metric ton of CO2 equivalent) of 2008 in Cyprus to that in Dominican Republic?
Keep it short and to the point. 0.09. What is the ratio of the Emissions (1000 metric ton of CO2 equivalent) of 1990 in Cyprus to that in Ecuador?
Keep it short and to the point. 0.07. What is the ratio of the Emissions (1000 metric ton of CO2 equivalent) of 2000 in Cyprus to that in Ecuador?
Make the answer very short. 0.05. What is the ratio of the Emissions (1000 metric ton of CO2 equivalent) of 2005 in Cyprus to that in Ecuador?
Offer a terse response. 0.05. What is the ratio of the Emissions (1000 metric ton of CO2 equivalent) of 2008 in Cyprus to that in Ecuador?
Provide a short and direct response. 0.04. What is the ratio of the Emissions (1000 metric ton of CO2 equivalent) in 1990 in Cyprus to that in Egypt, Arab Rep.?
Ensure brevity in your answer.  0.02. What is the ratio of the Emissions (1000 metric ton of CO2 equivalent) of 2000 in Cyprus to that in Egypt, Arab Rep.?
Offer a terse response. 0.01. What is the ratio of the Emissions (1000 metric ton of CO2 equivalent) in 2005 in Cyprus to that in Egypt, Arab Rep.?
Give a very brief answer. 0.01. What is the ratio of the Emissions (1000 metric ton of CO2 equivalent) in 2008 in Cyprus to that in Egypt, Arab Rep.?
Provide a short and direct response. 0.01. What is the ratio of the Emissions (1000 metric ton of CO2 equivalent) in 1990 in Czech Republic to that in Denmark?
Ensure brevity in your answer.  0.88. What is the ratio of the Emissions (1000 metric ton of CO2 equivalent) in 2000 in Czech Republic to that in Denmark?
Offer a very short reply. 0.66. What is the ratio of the Emissions (1000 metric ton of CO2 equivalent) in 2005 in Czech Republic to that in Denmark?
Offer a terse response. 0.71. What is the ratio of the Emissions (1000 metric ton of CO2 equivalent) in 2008 in Czech Republic to that in Denmark?
Make the answer very short. 0.69. What is the ratio of the Emissions (1000 metric ton of CO2 equivalent) of 1990 in Czech Republic to that in Dominican Republic?
Ensure brevity in your answer.  2.96. What is the ratio of the Emissions (1000 metric ton of CO2 equivalent) in 2000 in Czech Republic to that in Dominican Republic?
Your answer should be very brief. 2.02. What is the ratio of the Emissions (1000 metric ton of CO2 equivalent) of 2005 in Czech Republic to that in Dominican Republic?
Provide a short and direct response. 1.89. What is the ratio of the Emissions (1000 metric ton of CO2 equivalent) of 2008 in Czech Republic to that in Dominican Republic?
Offer a terse response. 1.73. What is the ratio of the Emissions (1000 metric ton of CO2 equivalent) of 1990 in Czech Republic to that in Ecuador?
Give a very brief answer. 1.9. What is the ratio of the Emissions (1000 metric ton of CO2 equivalent) in 2000 in Czech Republic to that in Ecuador?
Your answer should be compact. 0.91. What is the ratio of the Emissions (1000 metric ton of CO2 equivalent) of 2005 in Czech Republic to that in Ecuador?
Ensure brevity in your answer.  0.84. What is the ratio of the Emissions (1000 metric ton of CO2 equivalent) of 2008 in Czech Republic to that in Ecuador?
Offer a very short reply. 0.8. What is the ratio of the Emissions (1000 metric ton of CO2 equivalent) of 1990 in Czech Republic to that in Egypt, Arab Rep.?
Give a very brief answer. 0.61. What is the ratio of the Emissions (1000 metric ton of CO2 equivalent) in 2000 in Czech Republic to that in Egypt, Arab Rep.?
Your response must be concise. 0.26. What is the ratio of the Emissions (1000 metric ton of CO2 equivalent) in 2005 in Czech Republic to that in Egypt, Arab Rep.?
Your answer should be very brief. 0.22. What is the ratio of the Emissions (1000 metric ton of CO2 equivalent) in 2008 in Czech Republic to that in Egypt, Arab Rep.?
Your answer should be very brief. 0.18. What is the ratio of the Emissions (1000 metric ton of CO2 equivalent) in 1990 in Denmark to that in Dominican Republic?
Your answer should be very brief. 3.35. What is the ratio of the Emissions (1000 metric ton of CO2 equivalent) of 2000 in Denmark to that in Dominican Republic?
Offer a very short reply. 3.06. What is the ratio of the Emissions (1000 metric ton of CO2 equivalent) in 2005 in Denmark to that in Dominican Republic?
Make the answer very short. 2.67. What is the ratio of the Emissions (1000 metric ton of CO2 equivalent) in 2008 in Denmark to that in Dominican Republic?
Make the answer very short. 2.52. What is the ratio of the Emissions (1000 metric ton of CO2 equivalent) of 1990 in Denmark to that in Ecuador?
Make the answer very short. 2.15. What is the ratio of the Emissions (1000 metric ton of CO2 equivalent) in 2000 in Denmark to that in Ecuador?
Give a very brief answer. 1.38. What is the ratio of the Emissions (1000 metric ton of CO2 equivalent) of 2005 in Denmark to that in Ecuador?
Offer a very short reply. 1.19. What is the ratio of the Emissions (1000 metric ton of CO2 equivalent) in 2008 in Denmark to that in Ecuador?
Your answer should be compact. 1.17. What is the ratio of the Emissions (1000 metric ton of CO2 equivalent) in 1990 in Denmark to that in Egypt, Arab Rep.?
Offer a terse response. 0.69. What is the ratio of the Emissions (1000 metric ton of CO2 equivalent) of 2000 in Denmark to that in Egypt, Arab Rep.?
Provide a succinct answer. 0.4. What is the ratio of the Emissions (1000 metric ton of CO2 equivalent) of 2005 in Denmark to that in Egypt, Arab Rep.?
Your answer should be compact. 0.3. What is the ratio of the Emissions (1000 metric ton of CO2 equivalent) of 2008 in Denmark to that in Egypt, Arab Rep.?
Your answer should be compact. 0.27. What is the ratio of the Emissions (1000 metric ton of CO2 equivalent) of 1990 in Dominican Republic to that in Ecuador?
Provide a succinct answer. 0.64. What is the ratio of the Emissions (1000 metric ton of CO2 equivalent) in 2000 in Dominican Republic to that in Ecuador?
Give a very brief answer. 0.45. What is the ratio of the Emissions (1000 metric ton of CO2 equivalent) of 2005 in Dominican Republic to that in Ecuador?
Make the answer very short. 0.45. What is the ratio of the Emissions (1000 metric ton of CO2 equivalent) of 2008 in Dominican Republic to that in Ecuador?
Make the answer very short. 0.46. What is the ratio of the Emissions (1000 metric ton of CO2 equivalent) of 1990 in Dominican Republic to that in Egypt, Arab Rep.?
Your answer should be very brief. 0.21. What is the ratio of the Emissions (1000 metric ton of CO2 equivalent) in 2000 in Dominican Republic to that in Egypt, Arab Rep.?
Offer a very short reply. 0.13. What is the ratio of the Emissions (1000 metric ton of CO2 equivalent) of 2005 in Dominican Republic to that in Egypt, Arab Rep.?
Provide a short and direct response. 0.11. What is the ratio of the Emissions (1000 metric ton of CO2 equivalent) in 2008 in Dominican Republic to that in Egypt, Arab Rep.?
Ensure brevity in your answer.  0.11. What is the ratio of the Emissions (1000 metric ton of CO2 equivalent) of 1990 in Ecuador to that in Egypt, Arab Rep.?
Your answer should be compact. 0.32. What is the ratio of the Emissions (1000 metric ton of CO2 equivalent) of 2000 in Ecuador to that in Egypt, Arab Rep.?
Offer a terse response. 0.29. What is the ratio of the Emissions (1000 metric ton of CO2 equivalent) in 2005 in Ecuador to that in Egypt, Arab Rep.?
Your response must be concise. 0.26. What is the ratio of the Emissions (1000 metric ton of CO2 equivalent) of 2008 in Ecuador to that in Egypt, Arab Rep.?
Your answer should be very brief. 0.23. What is the difference between the highest and the second highest Emissions (1000 metric ton of CO2 equivalent) of 1990?
Provide a short and direct response. 2602.5. What is the difference between the highest and the second highest Emissions (1000 metric ton of CO2 equivalent) of 2000?
Your response must be concise. 7361.6. What is the difference between the highest and the second highest Emissions (1000 metric ton of CO2 equivalent) in 2005?
Keep it short and to the point. 1.06e+04. What is the difference between the highest and the second highest Emissions (1000 metric ton of CO2 equivalent) in 2008?
Your answer should be compact. 1.23e+04. What is the difference between the highest and the lowest Emissions (1000 metric ton of CO2 equivalent) in 1990?
Give a very brief answer. 8267. What is the difference between the highest and the lowest Emissions (1000 metric ton of CO2 equivalent) of 2000?
Provide a short and direct response. 1.20e+04. What is the difference between the highest and the lowest Emissions (1000 metric ton of CO2 equivalent) in 2005?
Make the answer very short. 1.50e+04. What is the difference between the highest and the lowest Emissions (1000 metric ton of CO2 equivalent) of 2008?
Offer a very short reply. 1.66e+04. 